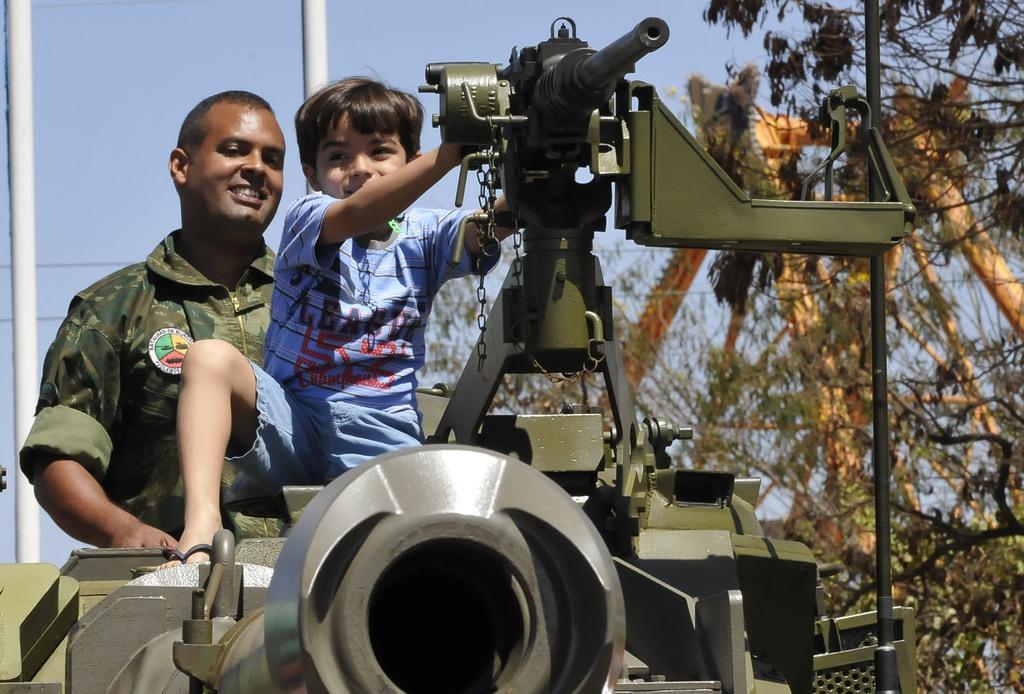Please provide a concise description of this image. Here I can see a boy wearing blue color t-shirt, short and sitting on a vehicle. At the back of this boy there is a man wearing uniform, smiling and looking at this boy. On the the right side there are some trees. On the left side, I can see two poles. On the top of the image I can see the sky. 